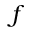<formula> <loc_0><loc_0><loc_500><loc_500>f</formula> 